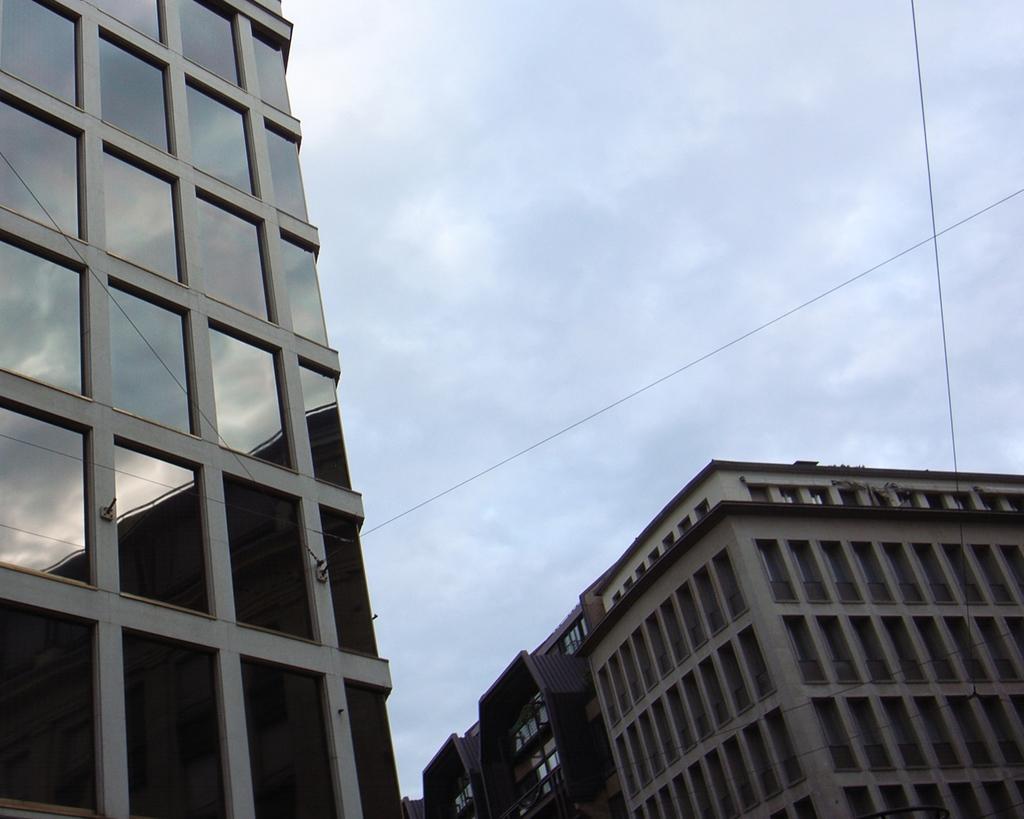How would you summarize this image in a sentence or two? In this image we can see some buildings with windows, wires and the sky which looks cloudy. 